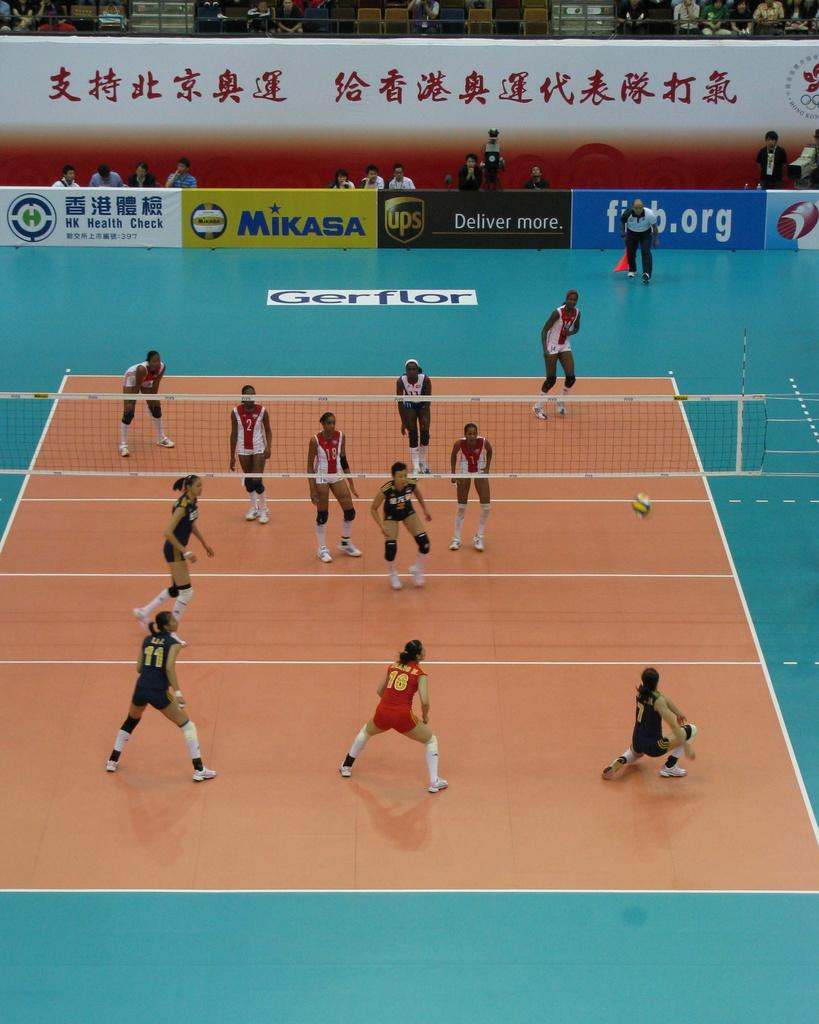Provide a one-sentence caption for the provided image. Mikasa and UPS are among the brands advertised at this volleyball game. 